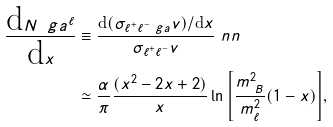Convert formula to latex. <formula><loc_0><loc_0><loc_500><loc_500>\frac { \text {d} N _ { \ } g a ^ { \ell } } { \text {d} x } & \equiv \frac { \text {d} ( \sigma _ { \ell ^ { + } \ell ^ { - } \ g a } v ) / \text {d} x } { \sigma _ { \ell ^ { + } \ell ^ { - } } v } \ n n \\ & \simeq \frac { \alpha } { \pi } \frac { ( x ^ { 2 } - 2 x + 2 ) } { x } \ln { \left [ \frac { m ^ { 2 } _ { \ B } } { m ^ { 2 } _ { \ell } } ( 1 - x ) \right ] } ,</formula> 